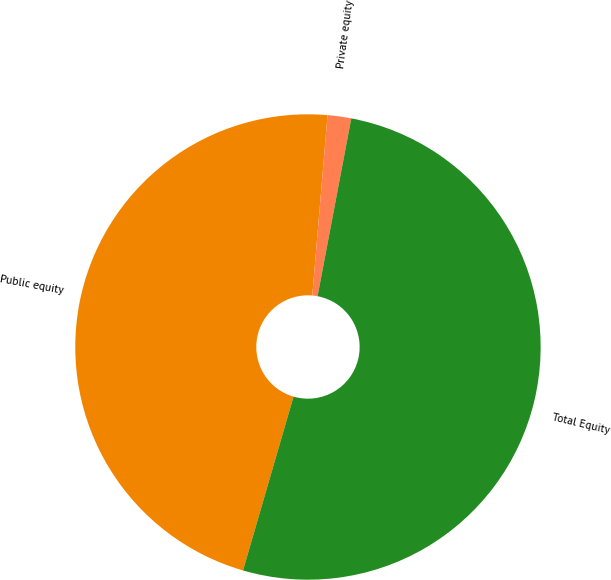Convert chart. <chart><loc_0><loc_0><loc_500><loc_500><pie_chart><fcel>Public equity<fcel>Private equity<fcel>Total Equity<nl><fcel>46.84%<fcel>1.64%<fcel>51.52%<nl></chart> 